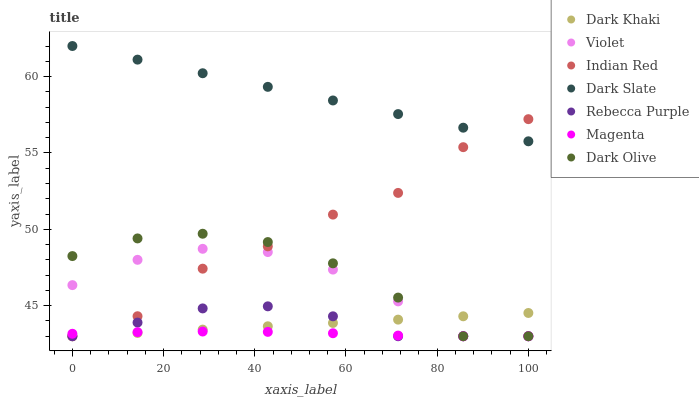Does Magenta have the minimum area under the curve?
Answer yes or no. Yes. Does Dark Slate have the maximum area under the curve?
Answer yes or no. Yes. Does Dark Khaki have the minimum area under the curve?
Answer yes or no. No. Does Dark Khaki have the maximum area under the curve?
Answer yes or no. No. Is Dark Khaki the smoothest?
Answer yes or no. Yes. Is Indian Red the roughest?
Answer yes or no. Yes. Is Dark Slate the smoothest?
Answer yes or no. No. Is Dark Slate the roughest?
Answer yes or no. No. Does Dark Olive have the lowest value?
Answer yes or no. Yes. Does Dark Slate have the lowest value?
Answer yes or no. No. Does Dark Slate have the highest value?
Answer yes or no. Yes. Does Dark Khaki have the highest value?
Answer yes or no. No. Is Dark Olive less than Dark Slate?
Answer yes or no. Yes. Is Dark Slate greater than Dark Olive?
Answer yes or no. Yes. Does Dark Khaki intersect Rebecca Purple?
Answer yes or no. Yes. Is Dark Khaki less than Rebecca Purple?
Answer yes or no. No. Is Dark Khaki greater than Rebecca Purple?
Answer yes or no. No. Does Dark Olive intersect Dark Slate?
Answer yes or no. No. 